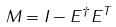<formula> <loc_0><loc_0><loc_500><loc_500>M = I - E ^ { \dagger } E ^ { T }</formula> 